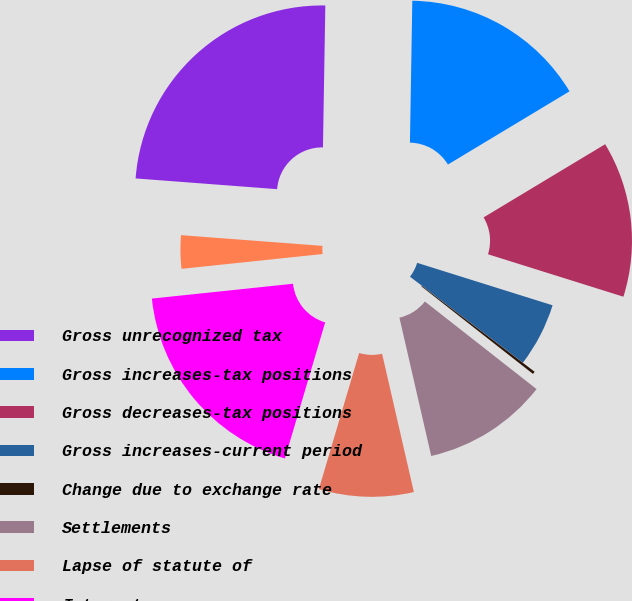<chart> <loc_0><loc_0><loc_500><loc_500><pie_chart><fcel>Gross unrecognized tax<fcel>Gross increases-tax positions<fcel>Gross decreases-tax positions<fcel>Gross increases-current period<fcel>Change due to exchange rate<fcel>Settlements<fcel>Lapse of statute of<fcel>Interest<fcel>Penalties<nl><fcel>24.06%<fcel>16.11%<fcel>13.46%<fcel>5.52%<fcel>0.23%<fcel>10.82%<fcel>8.17%<fcel>18.76%<fcel>2.87%<nl></chart> 